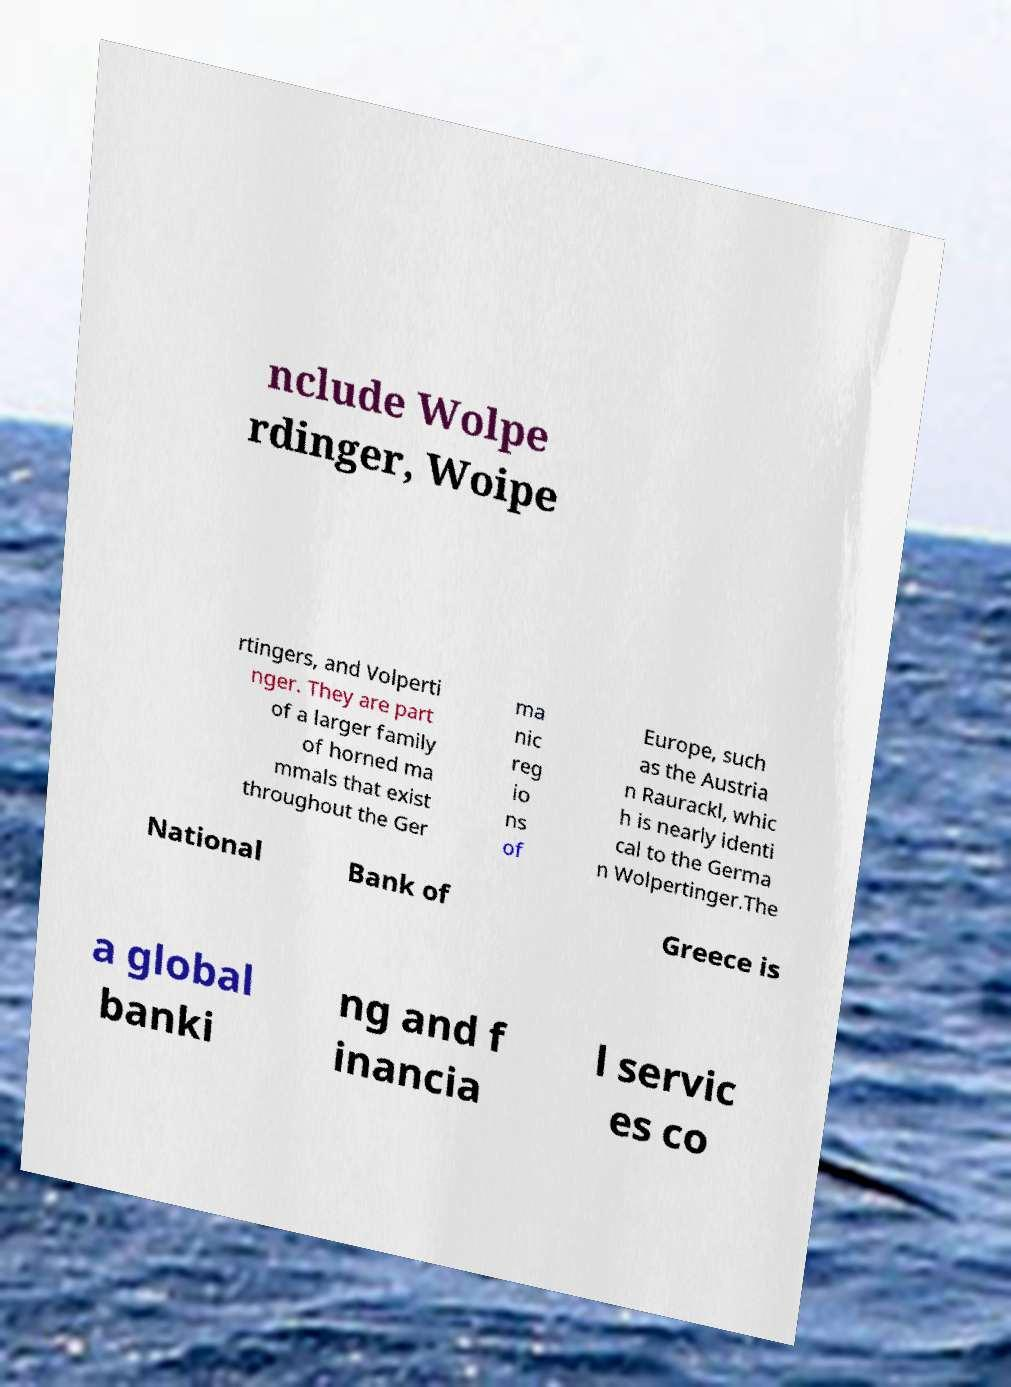Could you extract and type out the text from this image? nclude Wolpe rdinger, Woipe rtingers, and Volperti nger. They are part of a larger family of horned ma mmals that exist throughout the Ger ma nic reg io ns of Europe, such as the Austria n Raurackl, whic h is nearly identi cal to the Germa n Wolpertinger.The National Bank of Greece is a global banki ng and f inancia l servic es co 